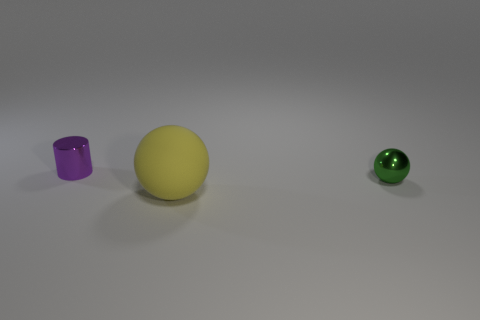Are there any big yellow objects of the same shape as the tiny green metallic thing?
Provide a short and direct response. Yes. What number of purple metallic cylinders are on the left side of the big yellow matte sphere?
Provide a short and direct response. 1. There is a sphere that is in front of the tiny shiny object right of the tiny purple metallic cylinder; what is its material?
Keep it short and to the point. Rubber. Are there any purple shiny cylinders that have the same size as the green ball?
Your response must be concise. Yes. What color is the metallic thing that is right of the small metallic cylinder?
Provide a short and direct response. Green. Are there any spheres that are in front of the green metal ball that is in front of the tiny purple object?
Keep it short and to the point. Yes. What number of other things are there of the same color as the large matte sphere?
Offer a very short reply. 0. Is the size of the object that is to the left of the large object the same as the shiny object that is right of the purple metal cylinder?
Offer a very short reply. Yes. There is a yellow matte thing that is in front of the shiny object on the left side of the tiny green metallic thing; what is its size?
Offer a very short reply. Large. There is a object that is behind the yellow rubber ball and left of the tiny metallic sphere; what is it made of?
Offer a very short reply. Metal. 